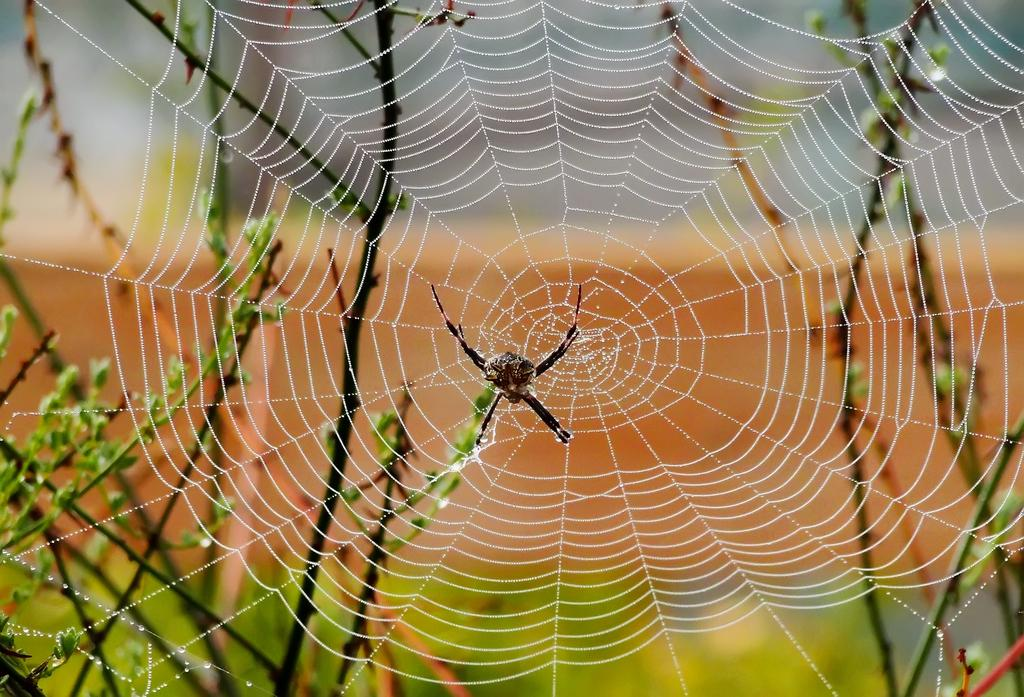What is the main subject of the image? The main subject of the image is a spider. Where is the spider located in the image? The spider is on a web. What else can be seen in the image besides the spider? A: There are plants visible in the image. Can you describe the describe the background of the image? The background of the image is blurred. What organization does the spider represent in the image? The image does not depict any organization, and the spider is not representing any organization. What journey is the spider taking in the image? The image does not show the spider taking any journey; it is stationary on the web. 